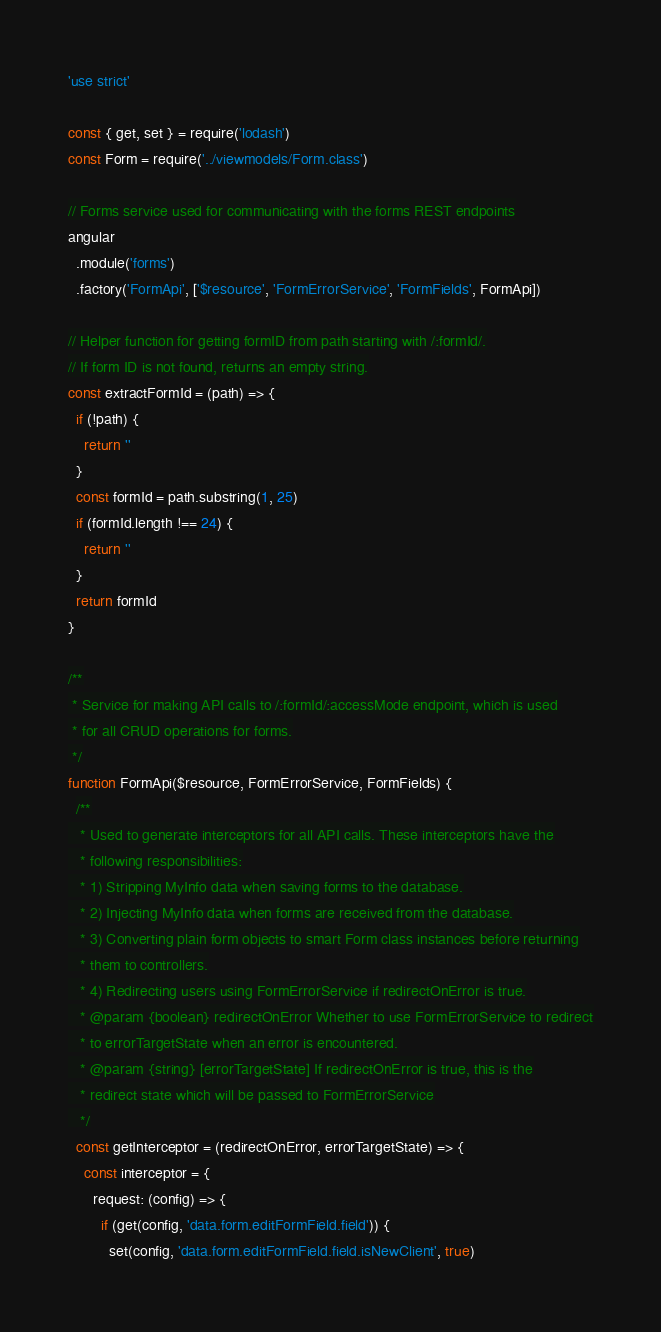<code> <loc_0><loc_0><loc_500><loc_500><_JavaScript_>'use strict'

const { get, set } = require('lodash')
const Form = require('../viewmodels/Form.class')

// Forms service used for communicating with the forms REST endpoints
angular
  .module('forms')
  .factory('FormApi', ['$resource', 'FormErrorService', 'FormFields', FormApi])

// Helper function for getting formID from path starting with /:formId/.
// If form ID is not found, returns an empty string.
const extractFormId = (path) => {
  if (!path) {
    return ''
  }
  const formId = path.substring(1, 25)
  if (formId.length !== 24) {
    return ''
  }
  return formId
}

/**
 * Service for making API calls to /:formId/:accessMode endpoint, which is used
 * for all CRUD operations for forms.
 */
function FormApi($resource, FormErrorService, FormFields) {
  /**
   * Used to generate interceptors for all API calls. These interceptors have the
   * following responsibilities:
   * 1) Stripping MyInfo data when saving forms to the database.
   * 2) Injecting MyInfo data when forms are received from the database.
   * 3) Converting plain form objects to smart Form class instances before returning
   * them to controllers.
   * 4) Redirecting users using FormErrorService if redirectOnError is true.
   * @param {boolean} redirectOnError Whether to use FormErrorService to redirect
   * to errorTargetState when an error is encountered.
   * @param {string} [errorTargetState] If redirectOnError is true, this is the
   * redirect state which will be passed to FormErrorService
   */
  const getInterceptor = (redirectOnError, errorTargetState) => {
    const interceptor = {
      request: (config) => {
        if (get(config, 'data.form.editFormField.field')) {
          set(config, 'data.form.editFormField.field.isNewClient', true) </code> 